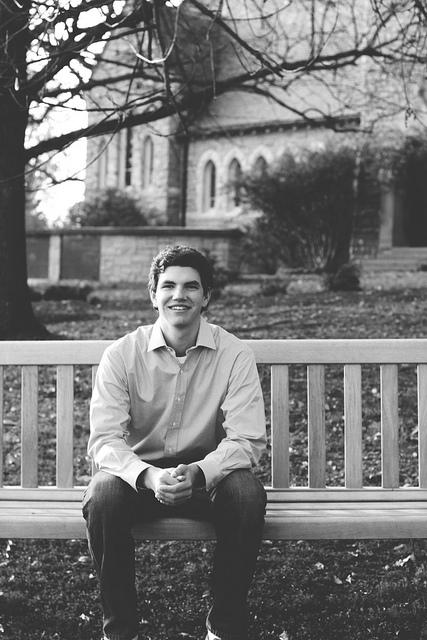What season of the year is it?
Give a very brief answer. Fall. Is the man seated outside his house?
Write a very short answer. No. Is the guy alone?
Give a very brief answer. Yes. What city skyline is that?
Short answer required. Minneapolis. Is the man traveling?
Quick response, please. No. Who is sitting on the bench?
Give a very brief answer. Man. Does the man has a mustache?
Keep it brief. No. 